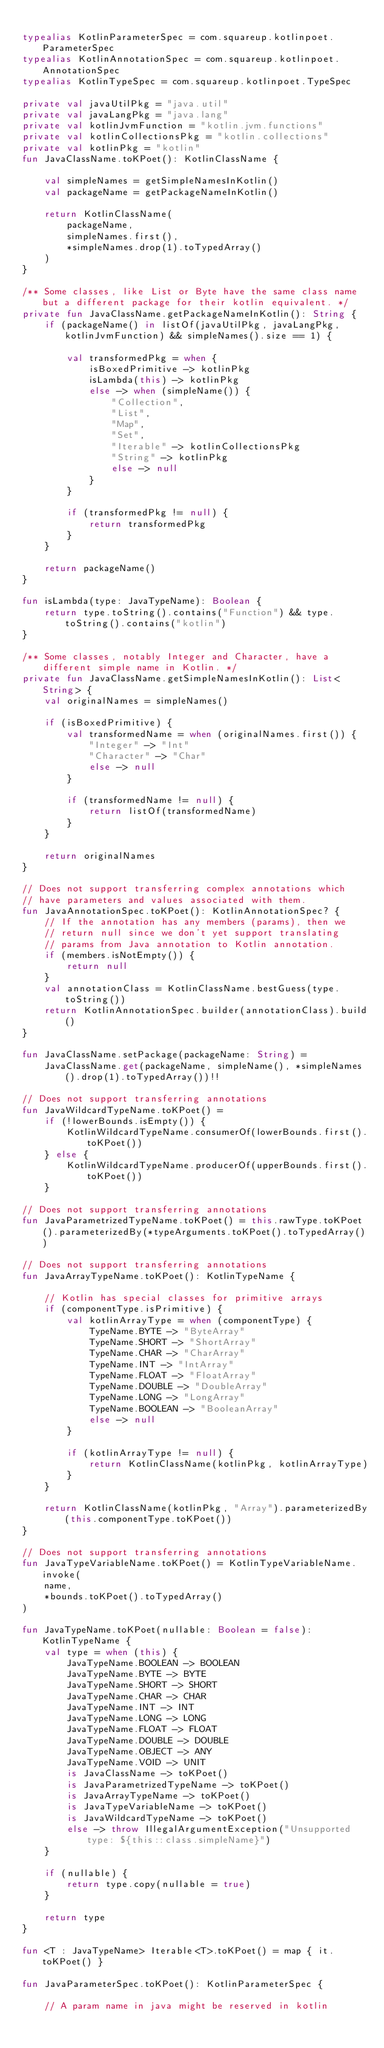<code> <loc_0><loc_0><loc_500><loc_500><_Kotlin_>
typealias KotlinParameterSpec = com.squareup.kotlinpoet.ParameterSpec
typealias KotlinAnnotationSpec = com.squareup.kotlinpoet.AnnotationSpec
typealias KotlinTypeSpec = com.squareup.kotlinpoet.TypeSpec

private val javaUtilPkg = "java.util"
private val javaLangPkg = "java.lang"
private val kotlinJvmFunction = "kotlin.jvm.functions"
private val kotlinCollectionsPkg = "kotlin.collections"
private val kotlinPkg = "kotlin"
fun JavaClassName.toKPoet(): KotlinClassName {

    val simpleNames = getSimpleNamesInKotlin()
    val packageName = getPackageNameInKotlin()

    return KotlinClassName(
        packageName,
        simpleNames.first(),
        *simpleNames.drop(1).toTypedArray()
    )
}

/** Some classes, like List or Byte have the same class name but a different package for their kotlin equivalent. */
private fun JavaClassName.getPackageNameInKotlin(): String {
    if (packageName() in listOf(javaUtilPkg, javaLangPkg, kotlinJvmFunction) && simpleNames().size == 1) {

        val transformedPkg = when {
            isBoxedPrimitive -> kotlinPkg
            isLambda(this) -> kotlinPkg
            else -> when (simpleName()) {
                "Collection",
                "List",
                "Map",
                "Set",
                "Iterable" -> kotlinCollectionsPkg
                "String" -> kotlinPkg
                else -> null
            }
        }

        if (transformedPkg != null) {
            return transformedPkg
        }
    }

    return packageName()
}

fun isLambda(type: JavaTypeName): Boolean {
    return type.toString().contains("Function") && type.toString().contains("kotlin")
}

/** Some classes, notably Integer and Character, have a different simple name in Kotlin. */
private fun JavaClassName.getSimpleNamesInKotlin(): List<String> {
    val originalNames = simpleNames()

    if (isBoxedPrimitive) {
        val transformedName = when (originalNames.first()) {
            "Integer" -> "Int"
            "Character" -> "Char"
            else -> null
        }

        if (transformedName != null) {
            return listOf(transformedName)
        }
    }

    return originalNames
}

// Does not support transferring complex annotations which
// have parameters and values associated with them.
fun JavaAnnotationSpec.toKPoet(): KotlinAnnotationSpec? {
    // If the annotation has any members (params), then we
    // return null since we don't yet support translating
    // params from Java annotation to Kotlin annotation.
    if (members.isNotEmpty()) {
        return null
    }
    val annotationClass = KotlinClassName.bestGuess(type.toString())
    return KotlinAnnotationSpec.builder(annotationClass).build()
}

fun JavaClassName.setPackage(packageName: String) =
    JavaClassName.get(packageName, simpleName(), *simpleNames().drop(1).toTypedArray())!!

// Does not support transferring annotations
fun JavaWildcardTypeName.toKPoet() =
    if (!lowerBounds.isEmpty()) {
        KotlinWildcardTypeName.consumerOf(lowerBounds.first().toKPoet())
    } else {
        KotlinWildcardTypeName.producerOf(upperBounds.first().toKPoet())
    }

// Does not support transferring annotations
fun JavaParametrizedTypeName.toKPoet() = this.rawType.toKPoet().parameterizedBy(*typeArguments.toKPoet().toTypedArray())

// Does not support transferring annotations
fun JavaArrayTypeName.toKPoet(): KotlinTypeName {

    // Kotlin has special classes for primitive arrays
    if (componentType.isPrimitive) {
        val kotlinArrayType = when (componentType) {
            TypeName.BYTE -> "ByteArray"
            TypeName.SHORT -> "ShortArray"
            TypeName.CHAR -> "CharArray"
            TypeName.INT -> "IntArray"
            TypeName.FLOAT -> "FloatArray"
            TypeName.DOUBLE -> "DoubleArray"
            TypeName.LONG -> "LongArray"
            TypeName.BOOLEAN -> "BooleanArray"
            else -> null
        }

        if (kotlinArrayType != null) {
            return KotlinClassName(kotlinPkg, kotlinArrayType)
        }
    }

    return KotlinClassName(kotlinPkg, "Array").parameterizedBy(this.componentType.toKPoet())
}

// Does not support transferring annotations
fun JavaTypeVariableName.toKPoet() = KotlinTypeVariableName.invoke(
    name,
    *bounds.toKPoet().toTypedArray()
)

fun JavaTypeName.toKPoet(nullable: Boolean = false): KotlinTypeName {
    val type = when (this) {
        JavaTypeName.BOOLEAN -> BOOLEAN
        JavaTypeName.BYTE -> BYTE
        JavaTypeName.SHORT -> SHORT
        JavaTypeName.CHAR -> CHAR
        JavaTypeName.INT -> INT
        JavaTypeName.LONG -> LONG
        JavaTypeName.FLOAT -> FLOAT
        JavaTypeName.DOUBLE -> DOUBLE
        JavaTypeName.OBJECT -> ANY
        JavaTypeName.VOID -> UNIT
        is JavaClassName -> toKPoet()
        is JavaParametrizedTypeName -> toKPoet()
        is JavaArrayTypeName -> toKPoet()
        is JavaTypeVariableName -> toKPoet()
        is JavaWildcardTypeName -> toKPoet()
        else -> throw IllegalArgumentException("Unsupported type: ${this::class.simpleName}")
    }

    if (nullable) {
        return type.copy(nullable = true)
    }

    return type
}

fun <T : JavaTypeName> Iterable<T>.toKPoet() = map { it.toKPoet() }

fun JavaParameterSpec.toKPoet(): KotlinParameterSpec {

    // A param name in java might be reserved in kotlin</code> 